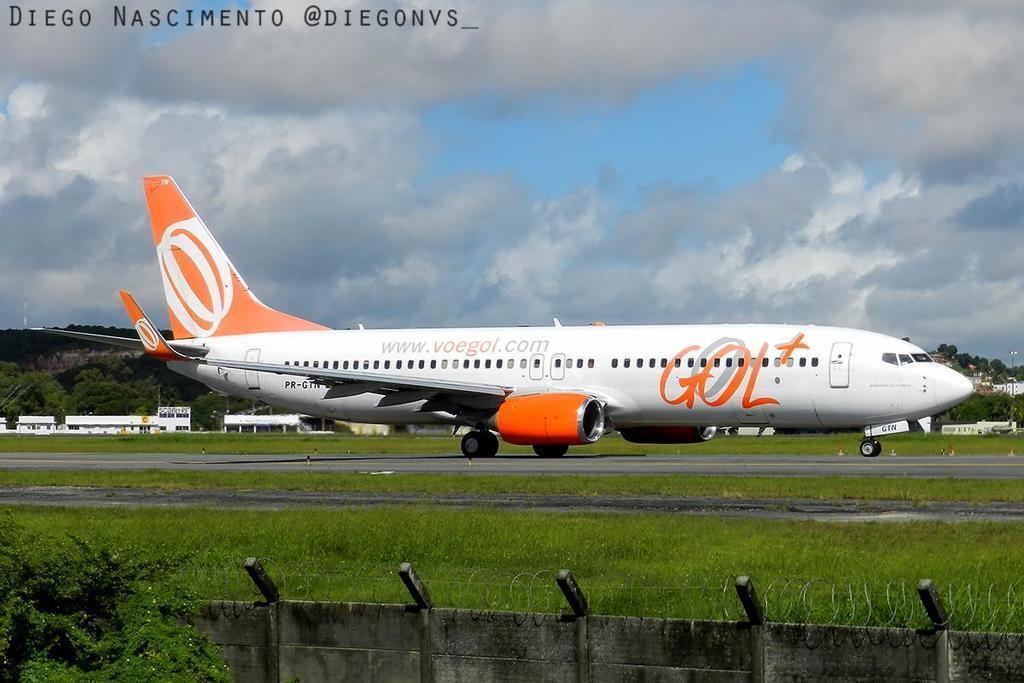Can you describe this image briefly? This picture is clicked outside. In the center we can see an airplane and we can see the green grass, plants, buildings and some other objects. In the background we can see the sky which is full of clouds and we can see the trees and in the top left corner we can see the text on the image. 